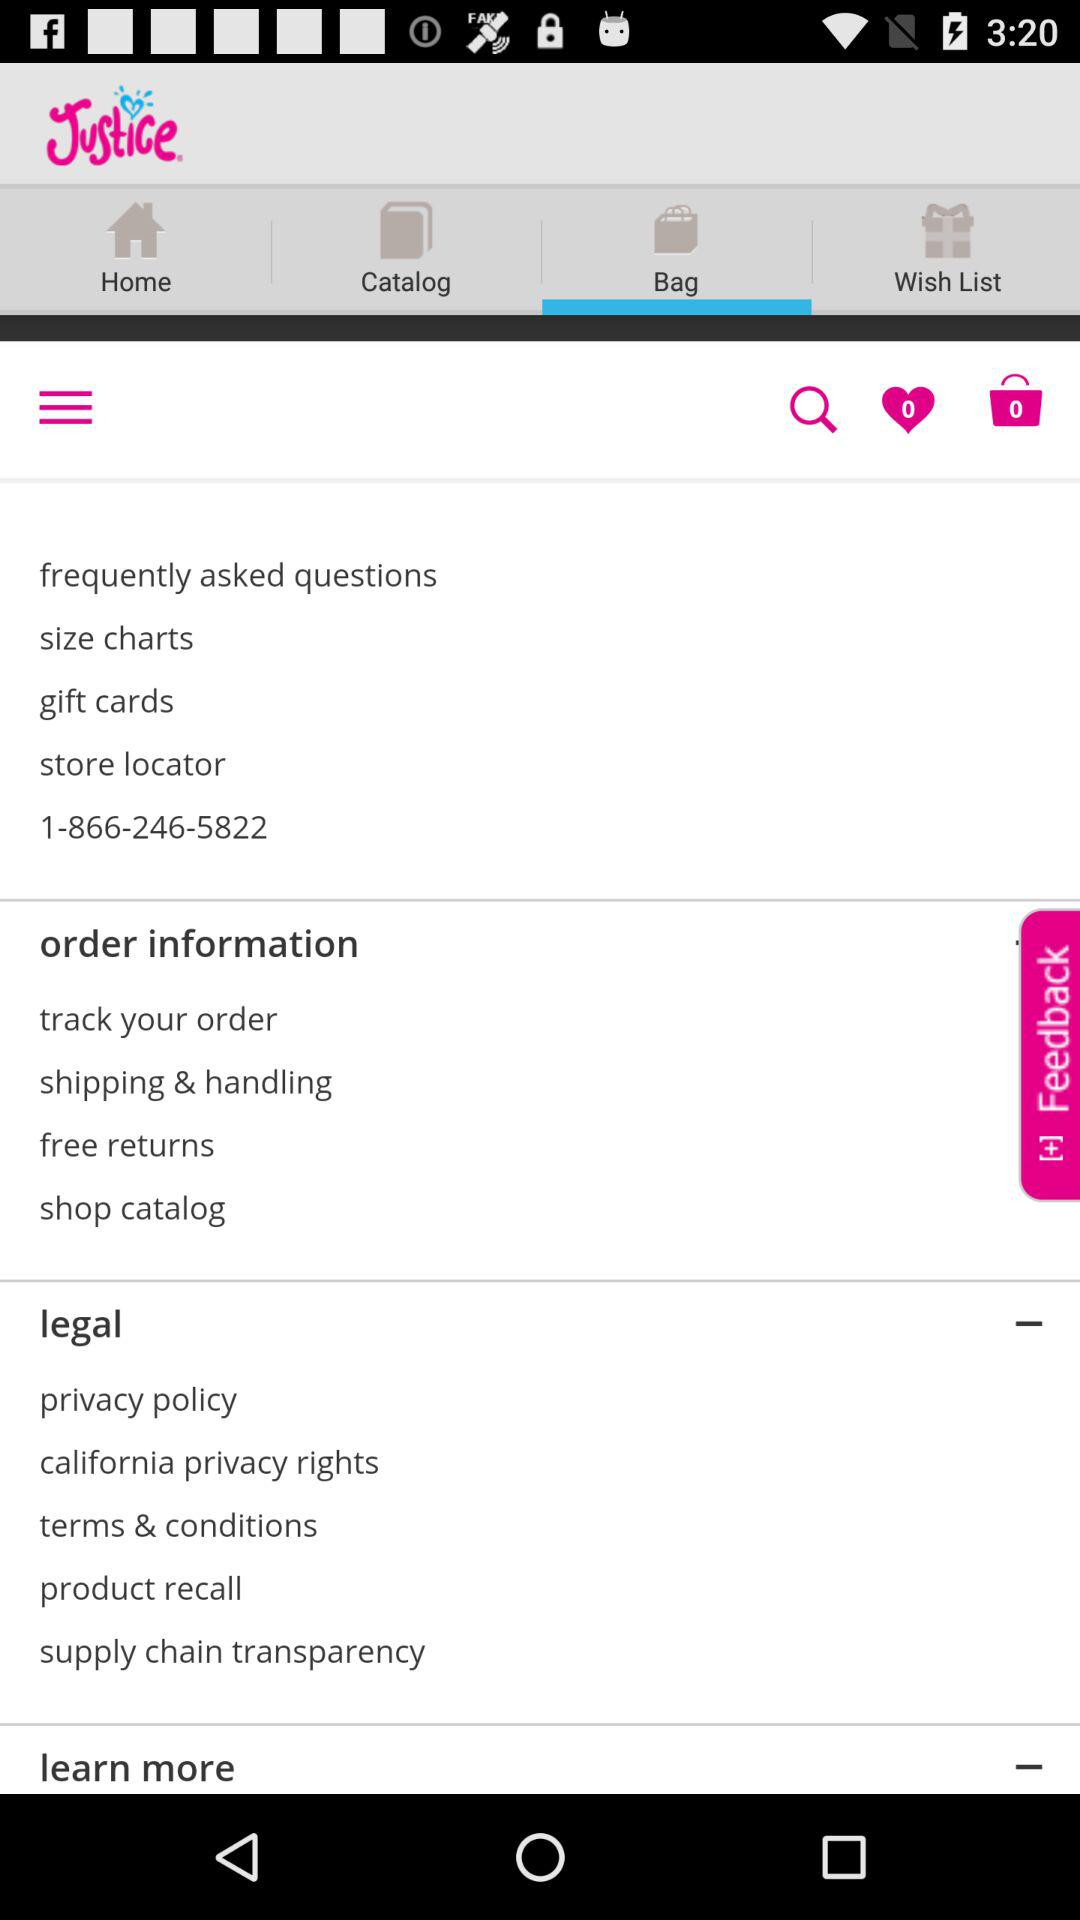How many items are in the bag? There are 0 items in the bag. 